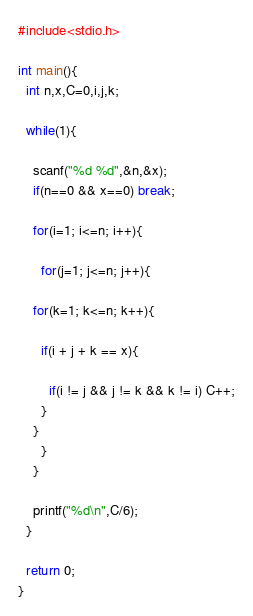Convert code to text. <code><loc_0><loc_0><loc_500><loc_500><_C_>#include<stdio.h>

int main(){
  int n,x,C=0,i,j,k;

  while(1){

    scanf("%d %d",&n,&x);
    if(n==0 && x==0) break;

    for(i=1; i<=n; i++){

      for(j=1; j<=n; j++){

	for(k=1; k<=n; k++){

	  if(i + j + k == x){

	    if(i != j && j != k && k != i) C++;
	  }
	}
      }
    }
  
    printf("%d\n",C/6);
  }

  return 0;
}</code> 